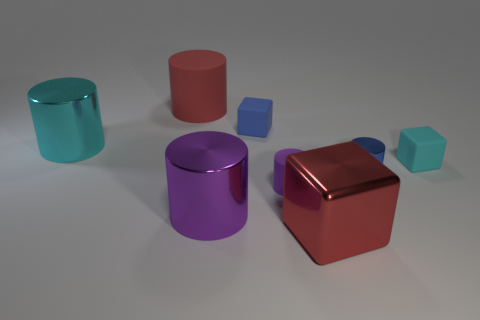Which objects in the image could be associated with a particular theme or concept? The objects in the image could potentially be used to discuss themes of individuality and uniqueness, as each object has a distinct color, implying that they all have their own identity. They could also illustrate a concept in geometry or a lesson on shapes and colors in an educational setting. How would you use these objects to illustrate a concept in geometry? Using these objects, one could illustrate the concepts of volume and surface area. For example, we can observe that despite having different shapes, some of the objects might have similar volumes or surface areas. Additionally, one could compare the differences between the cubes and cylinders in terms of their number of faces, edges, and vertices. 